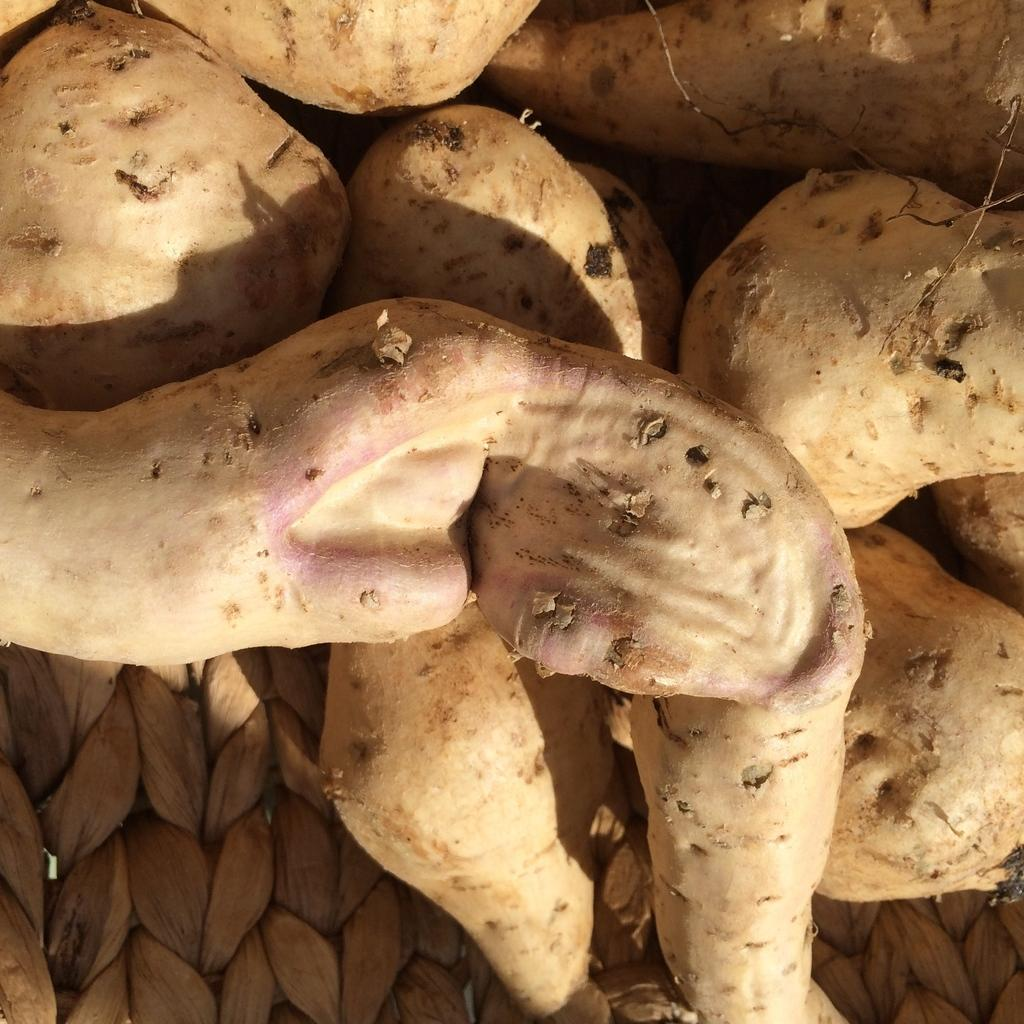What type of food is present in the image? There are sweet potatoes in the image. What is the sweet potatoes placed on? The sweet potatoes are on an object. What type of dress is being worn by the sweet potatoes in the image? There is no dress present in the image, as sweet potatoes are a type of food and not capable of wearing clothing. 